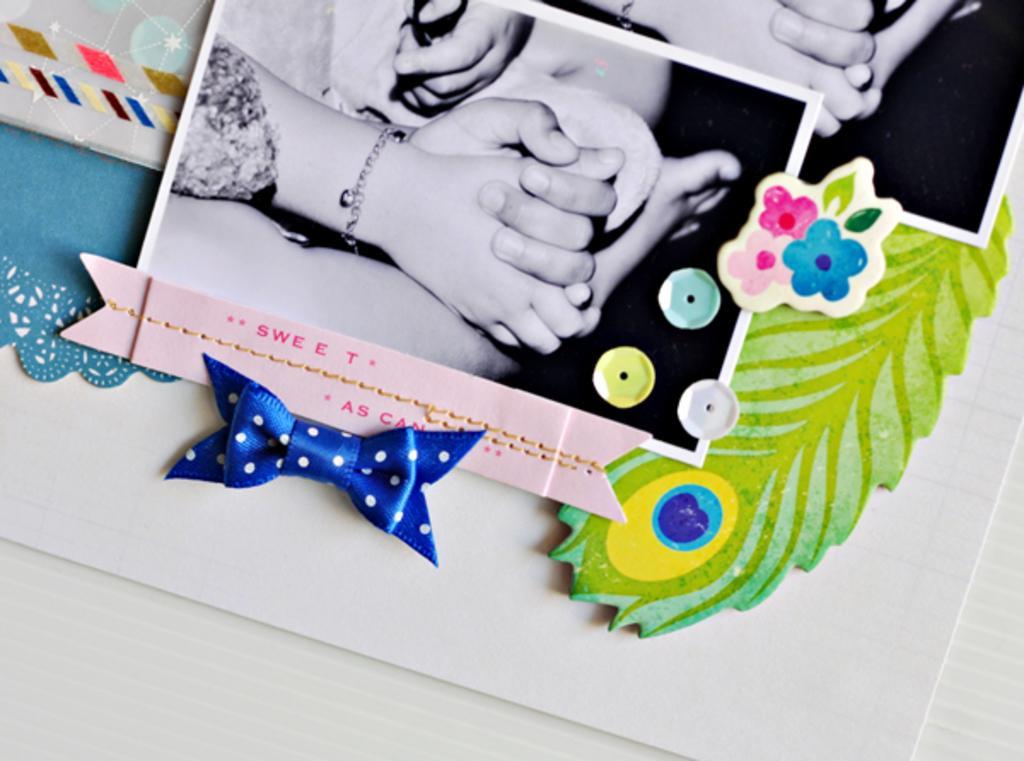Please provide a concise description of this image. In this image, we can see the ground. We can also see some photocopies and crafted objects. We can also see some objects on the left. 